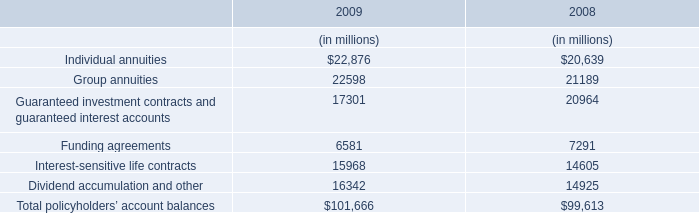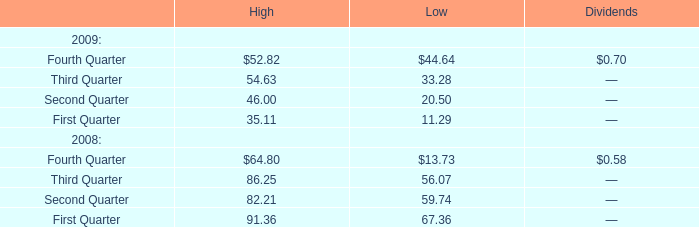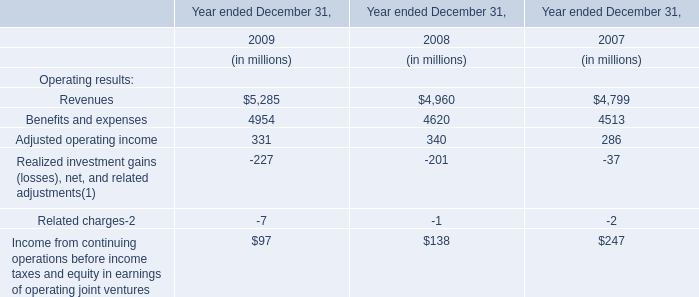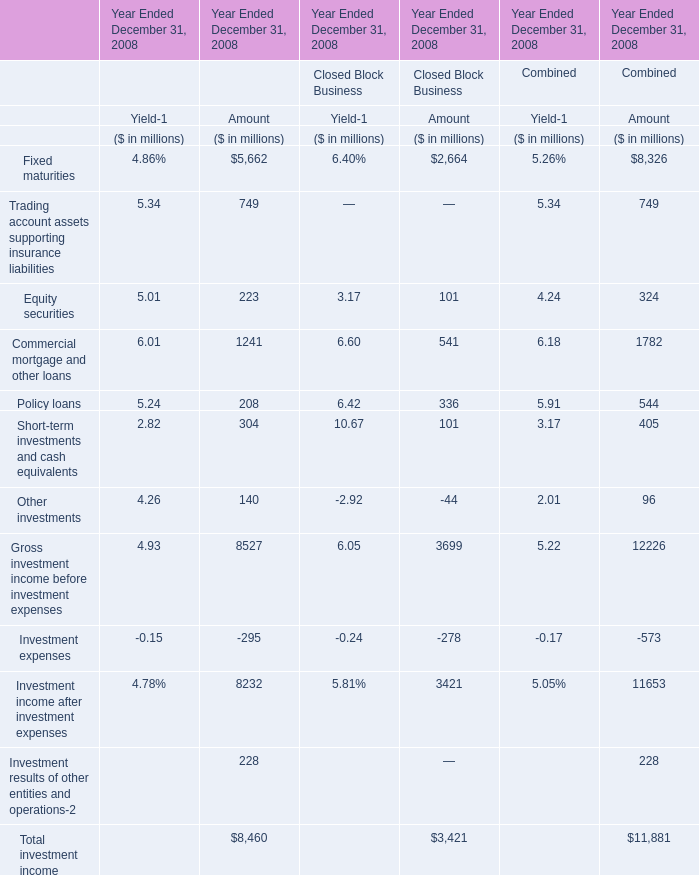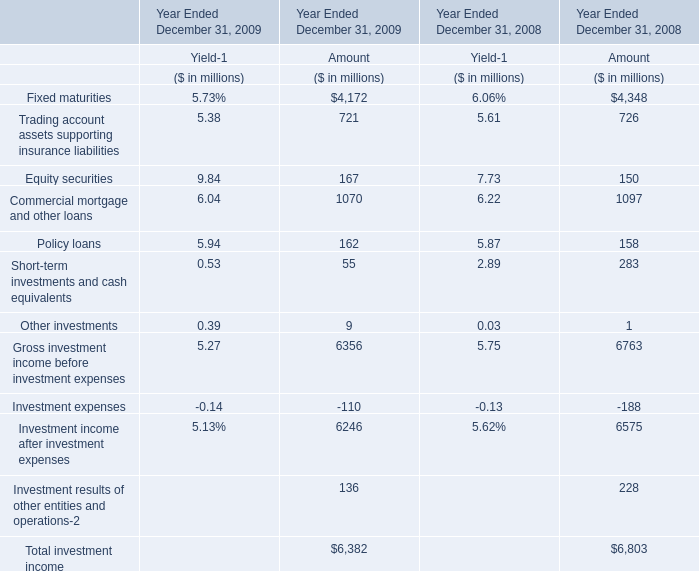Which year is Policy loans for Amount the highest? 
Answer: 2009. 